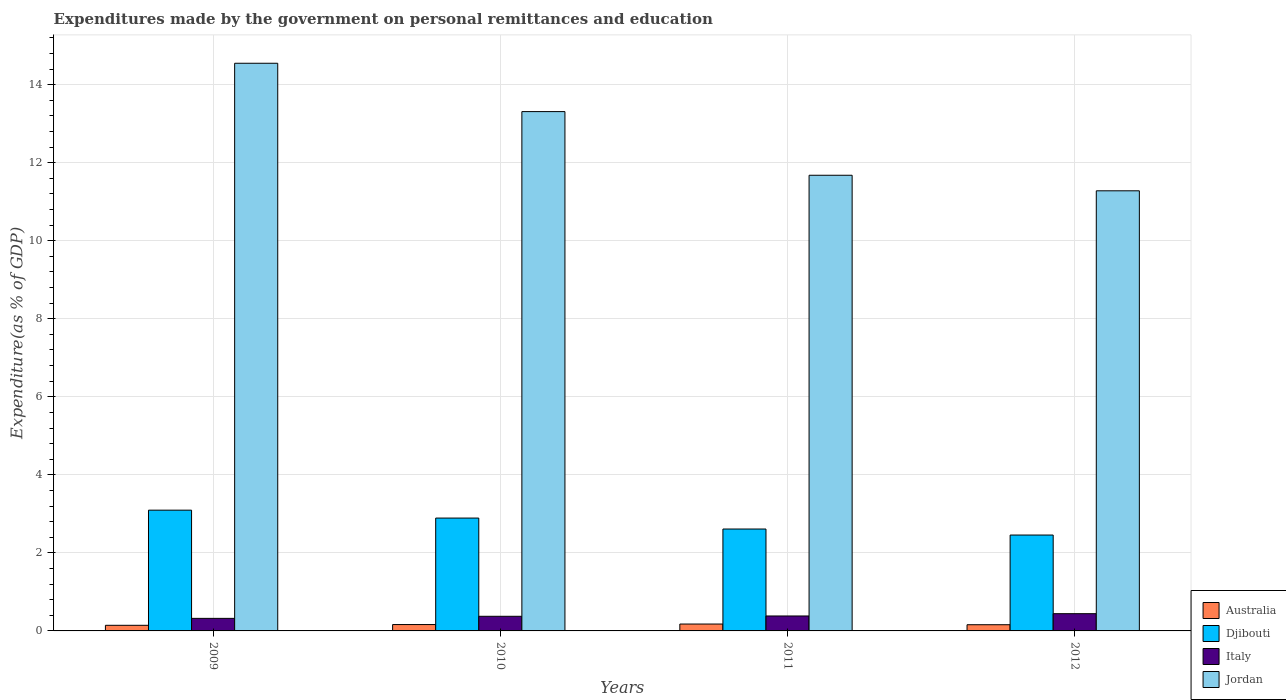How many groups of bars are there?
Ensure brevity in your answer.  4. Are the number of bars on each tick of the X-axis equal?
Provide a short and direct response. Yes. How many bars are there on the 1st tick from the left?
Your answer should be compact. 4. What is the expenditures made by the government on personal remittances and education in Australia in 2011?
Ensure brevity in your answer.  0.18. Across all years, what is the maximum expenditures made by the government on personal remittances and education in Australia?
Offer a very short reply. 0.18. Across all years, what is the minimum expenditures made by the government on personal remittances and education in Djibouti?
Your response must be concise. 2.46. What is the total expenditures made by the government on personal remittances and education in Italy in the graph?
Ensure brevity in your answer.  1.52. What is the difference between the expenditures made by the government on personal remittances and education in Australia in 2010 and that in 2012?
Make the answer very short. 0. What is the difference between the expenditures made by the government on personal remittances and education in Australia in 2011 and the expenditures made by the government on personal remittances and education in Jordan in 2009?
Your answer should be very brief. -14.37. What is the average expenditures made by the government on personal remittances and education in Italy per year?
Offer a terse response. 0.38. In the year 2011, what is the difference between the expenditures made by the government on personal remittances and education in Italy and expenditures made by the government on personal remittances and education in Jordan?
Keep it short and to the point. -11.3. In how many years, is the expenditures made by the government on personal remittances and education in Djibouti greater than 2.8 %?
Provide a succinct answer. 2. What is the ratio of the expenditures made by the government on personal remittances and education in Australia in 2009 to that in 2010?
Offer a very short reply. 0.88. Is the expenditures made by the government on personal remittances and education in Jordan in 2011 less than that in 2012?
Make the answer very short. No. What is the difference between the highest and the second highest expenditures made by the government on personal remittances and education in Australia?
Ensure brevity in your answer.  0.01. What is the difference between the highest and the lowest expenditures made by the government on personal remittances and education in Djibouti?
Keep it short and to the point. 0.64. What does the 4th bar from the left in 2009 represents?
Provide a short and direct response. Jordan. Is it the case that in every year, the sum of the expenditures made by the government on personal remittances and education in Italy and expenditures made by the government on personal remittances and education in Djibouti is greater than the expenditures made by the government on personal remittances and education in Jordan?
Provide a succinct answer. No. Does the graph contain grids?
Offer a terse response. Yes. How many legend labels are there?
Ensure brevity in your answer.  4. What is the title of the graph?
Provide a succinct answer. Expenditures made by the government on personal remittances and education. Does "Aruba" appear as one of the legend labels in the graph?
Provide a short and direct response. No. What is the label or title of the X-axis?
Your response must be concise. Years. What is the label or title of the Y-axis?
Your answer should be compact. Expenditure(as % of GDP). What is the Expenditure(as % of GDP) in Australia in 2009?
Keep it short and to the point. 0.14. What is the Expenditure(as % of GDP) in Djibouti in 2009?
Offer a terse response. 3.09. What is the Expenditure(as % of GDP) in Italy in 2009?
Provide a short and direct response. 0.32. What is the Expenditure(as % of GDP) in Jordan in 2009?
Ensure brevity in your answer.  14.55. What is the Expenditure(as % of GDP) of Australia in 2010?
Provide a succinct answer. 0.16. What is the Expenditure(as % of GDP) of Djibouti in 2010?
Provide a succinct answer. 2.89. What is the Expenditure(as % of GDP) of Italy in 2010?
Ensure brevity in your answer.  0.38. What is the Expenditure(as % of GDP) of Jordan in 2010?
Your response must be concise. 13.31. What is the Expenditure(as % of GDP) of Australia in 2011?
Ensure brevity in your answer.  0.18. What is the Expenditure(as % of GDP) in Djibouti in 2011?
Ensure brevity in your answer.  2.61. What is the Expenditure(as % of GDP) of Italy in 2011?
Offer a very short reply. 0.38. What is the Expenditure(as % of GDP) in Jordan in 2011?
Your answer should be very brief. 11.68. What is the Expenditure(as % of GDP) in Australia in 2012?
Give a very brief answer. 0.16. What is the Expenditure(as % of GDP) in Djibouti in 2012?
Your answer should be compact. 2.46. What is the Expenditure(as % of GDP) of Italy in 2012?
Your answer should be compact. 0.44. What is the Expenditure(as % of GDP) in Jordan in 2012?
Ensure brevity in your answer.  11.28. Across all years, what is the maximum Expenditure(as % of GDP) in Australia?
Keep it short and to the point. 0.18. Across all years, what is the maximum Expenditure(as % of GDP) of Djibouti?
Make the answer very short. 3.09. Across all years, what is the maximum Expenditure(as % of GDP) in Italy?
Offer a very short reply. 0.44. Across all years, what is the maximum Expenditure(as % of GDP) of Jordan?
Provide a short and direct response. 14.55. Across all years, what is the minimum Expenditure(as % of GDP) in Australia?
Your answer should be very brief. 0.14. Across all years, what is the minimum Expenditure(as % of GDP) of Djibouti?
Provide a succinct answer. 2.46. Across all years, what is the minimum Expenditure(as % of GDP) in Italy?
Provide a succinct answer. 0.32. Across all years, what is the minimum Expenditure(as % of GDP) of Jordan?
Keep it short and to the point. 11.28. What is the total Expenditure(as % of GDP) in Australia in the graph?
Ensure brevity in your answer.  0.64. What is the total Expenditure(as % of GDP) of Djibouti in the graph?
Provide a succinct answer. 11.06. What is the total Expenditure(as % of GDP) of Italy in the graph?
Provide a succinct answer. 1.52. What is the total Expenditure(as % of GDP) in Jordan in the graph?
Offer a terse response. 50.82. What is the difference between the Expenditure(as % of GDP) of Australia in 2009 and that in 2010?
Your response must be concise. -0.02. What is the difference between the Expenditure(as % of GDP) in Djibouti in 2009 and that in 2010?
Give a very brief answer. 0.2. What is the difference between the Expenditure(as % of GDP) of Italy in 2009 and that in 2010?
Keep it short and to the point. -0.05. What is the difference between the Expenditure(as % of GDP) of Jordan in 2009 and that in 2010?
Your answer should be very brief. 1.24. What is the difference between the Expenditure(as % of GDP) of Australia in 2009 and that in 2011?
Your answer should be very brief. -0.03. What is the difference between the Expenditure(as % of GDP) in Djibouti in 2009 and that in 2011?
Offer a very short reply. 0.48. What is the difference between the Expenditure(as % of GDP) of Italy in 2009 and that in 2011?
Provide a short and direct response. -0.06. What is the difference between the Expenditure(as % of GDP) of Jordan in 2009 and that in 2011?
Give a very brief answer. 2.87. What is the difference between the Expenditure(as % of GDP) of Australia in 2009 and that in 2012?
Your response must be concise. -0.01. What is the difference between the Expenditure(as % of GDP) of Djibouti in 2009 and that in 2012?
Your response must be concise. 0.64. What is the difference between the Expenditure(as % of GDP) in Italy in 2009 and that in 2012?
Make the answer very short. -0.12. What is the difference between the Expenditure(as % of GDP) of Jordan in 2009 and that in 2012?
Give a very brief answer. 3.27. What is the difference between the Expenditure(as % of GDP) in Australia in 2010 and that in 2011?
Your answer should be very brief. -0.01. What is the difference between the Expenditure(as % of GDP) in Djibouti in 2010 and that in 2011?
Offer a terse response. 0.28. What is the difference between the Expenditure(as % of GDP) of Italy in 2010 and that in 2011?
Ensure brevity in your answer.  -0.01. What is the difference between the Expenditure(as % of GDP) of Jordan in 2010 and that in 2011?
Keep it short and to the point. 1.63. What is the difference between the Expenditure(as % of GDP) of Australia in 2010 and that in 2012?
Offer a very short reply. 0. What is the difference between the Expenditure(as % of GDP) in Djibouti in 2010 and that in 2012?
Keep it short and to the point. 0.43. What is the difference between the Expenditure(as % of GDP) in Italy in 2010 and that in 2012?
Your response must be concise. -0.07. What is the difference between the Expenditure(as % of GDP) of Jordan in 2010 and that in 2012?
Your answer should be compact. 2.03. What is the difference between the Expenditure(as % of GDP) in Australia in 2011 and that in 2012?
Your response must be concise. 0.02. What is the difference between the Expenditure(as % of GDP) of Djibouti in 2011 and that in 2012?
Provide a short and direct response. 0.15. What is the difference between the Expenditure(as % of GDP) of Italy in 2011 and that in 2012?
Your answer should be compact. -0.06. What is the difference between the Expenditure(as % of GDP) of Jordan in 2011 and that in 2012?
Keep it short and to the point. 0.4. What is the difference between the Expenditure(as % of GDP) of Australia in 2009 and the Expenditure(as % of GDP) of Djibouti in 2010?
Give a very brief answer. -2.75. What is the difference between the Expenditure(as % of GDP) in Australia in 2009 and the Expenditure(as % of GDP) in Italy in 2010?
Provide a short and direct response. -0.23. What is the difference between the Expenditure(as % of GDP) in Australia in 2009 and the Expenditure(as % of GDP) in Jordan in 2010?
Provide a succinct answer. -13.17. What is the difference between the Expenditure(as % of GDP) of Djibouti in 2009 and the Expenditure(as % of GDP) of Italy in 2010?
Ensure brevity in your answer.  2.72. What is the difference between the Expenditure(as % of GDP) of Djibouti in 2009 and the Expenditure(as % of GDP) of Jordan in 2010?
Offer a terse response. -10.21. What is the difference between the Expenditure(as % of GDP) of Italy in 2009 and the Expenditure(as % of GDP) of Jordan in 2010?
Provide a succinct answer. -12.99. What is the difference between the Expenditure(as % of GDP) in Australia in 2009 and the Expenditure(as % of GDP) in Djibouti in 2011?
Provide a short and direct response. -2.47. What is the difference between the Expenditure(as % of GDP) of Australia in 2009 and the Expenditure(as % of GDP) of Italy in 2011?
Give a very brief answer. -0.24. What is the difference between the Expenditure(as % of GDP) of Australia in 2009 and the Expenditure(as % of GDP) of Jordan in 2011?
Provide a succinct answer. -11.53. What is the difference between the Expenditure(as % of GDP) in Djibouti in 2009 and the Expenditure(as % of GDP) in Italy in 2011?
Keep it short and to the point. 2.71. What is the difference between the Expenditure(as % of GDP) in Djibouti in 2009 and the Expenditure(as % of GDP) in Jordan in 2011?
Make the answer very short. -8.58. What is the difference between the Expenditure(as % of GDP) in Italy in 2009 and the Expenditure(as % of GDP) in Jordan in 2011?
Provide a short and direct response. -11.36. What is the difference between the Expenditure(as % of GDP) of Australia in 2009 and the Expenditure(as % of GDP) of Djibouti in 2012?
Offer a very short reply. -2.31. What is the difference between the Expenditure(as % of GDP) of Australia in 2009 and the Expenditure(as % of GDP) of Italy in 2012?
Offer a very short reply. -0.3. What is the difference between the Expenditure(as % of GDP) in Australia in 2009 and the Expenditure(as % of GDP) in Jordan in 2012?
Give a very brief answer. -11.14. What is the difference between the Expenditure(as % of GDP) in Djibouti in 2009 and the Expenditure(as % of GDP) in Italy in 2012?
Your response must be concise. 2.65. What is the difference between the Expenditure(as % of GDP) of Djibouti in 2009 and the Expenditure(as % of GDP) of Jordan in 2012?
Keep it short and to the point. -8.18. What is the difference between the Expenditure(as % of GDP) of Italy in 2009 and the Expenditure(as % of GDP) of Jordan in 2012?
Ensure brevity in your answer.  -10.96. What is the difference between the Expenditure(as % of GDP) in Australia in 2010 and the Expenditure(as % of GDP) in Djibouti in 2011?
Provide a succinct answer. -2.45. What is the difference between the Expenditure(as % of GDP) of Australia in 2010 and the Expenditure(as % of GDP) of Italy in 2011?
Provide a succinct answer. -0.22. What is the difference between the Expenditure(as % of GDP) of Australia in 2010 and the Expenditure(as % of GDP) of Jordan in 2011?
Ensure brevity in your answer.  -11.52. What is the difference between the Expenditure(as % of GDP) in Djibouti in 2010 and the Expenditure(as % of GDP) in Italy in 2011?
Offer a very short reply. 2.51. What is the difference between the Expenditure(as % of GDP) of Djibouti in 2010 and the Expenditure(as % of GDP) of Jordan in 2011?
Make the answer very short. -8.79. What is the difference between the Expenditure(as % of GDP) of Italy in 2010 and the Expenditure(as % of GDP) of Jordan in 2011?
Ensure brevity in your answer.  -11.3. What is the difference between the Expenditure(as % of GDP) in Australia in 2010 and the Expenditure(as % of GDP) in Djibouti in 2012?
Provide a succinct answer. -2.29. What is the difference between the Expenditure(as % of GDP) in Australia in 2010 and the Expenditure(as % of GDP) in Italy in 2012?
Make the answer very short. -0.28. What is the difference between the Expenditure(as % of GDP) in Australia in 2010 and the Expenditure(as % of GDP) in Jordan in 2012?
Give a very brief answer. -11.12. What is the difference between the Expenditure(as % of GDP) of Djibouti in 2010 and the Expenditure(as % of GDP) of Italy in 2012?
Offer a terse response. 2.45. What is the difference between the Expenditure(as % of GDP) of Djibouti in 2010 and the Expenditure(as % of GDP) of Jordan in 2012?
Give a very brief answer. -8.39. What is the difference between the Expenditure(as % of GDP) in Italy in 2010 and the Expenditure(as % of GDP) in Jordan in 2012?
Your answer should be very brief. -10.9. What is the difference between the Expenditure(as % of GDP) of Australia in 2011 and the Expenditure(as % of GDP) of Djibouti in 2012?
Provide a short and direct response. -2.28. What is the difference between the Expenditure(as % of GDP) of Australia in 2011 and the Expenditure(as % of GDP) of Italy in 2012?
Make the answer very short. -0.27. What is the difference between the Expenditure(as % of GDP) of Australia in 2011 and the Expenditure(as % of GDP) of Jordan in 2012?
Provide a succinct answer. -11.1. What is the difference between the Expenditure(as % of GDP) of Djibouti in 2011 and the Expenditure(as % of GDP) of Italy in 2012?
Your response must be concise. 2.17. What is the difference between the Expenditure(as % of GDP) of Djibouti in 2011 and the Expenditure(as % of GDP) of Jordan in 2012?
Keep it short and to the point. -8.67. What is the difference between the Expenditure(as % of GDP) in Italy in 2011 and the Expenditure(as % of GDP) in Jordan in 2012?
Offer a very short reply. -10.9. What is the average Expenditure(as % of GDP) in Australia per year?
Your answer should be compact. 0.16. What is the average Expenditure(as % of GDP) of Djibouti per year?
Make the answer very short. 2.76. What is the average Expenditure(as % of GDP) in Italy per year?
Your response must be concise. 0.38. What is the average Expenditure(as % of GDP) in Jordan per year?
Your response must be concise. 12.7. In the year 2009, what is the difference between the Expenditure(as % of GDP) in Australia and Expenditure(as % of GDP) in Djibouti?
Ensure brevity in your answer.  -2.95. In the year 2009, what is the difference between the Expenditure(as % of GDP) in Australia and Expenditure(as % of GDP) in Italy?
Give a very brief answer. -0.18. In the year 2009, what is the difference between the Expenditure(as % of GDP) of Australia and Expenditure(as % of GDP) of Jordan?
Offer a very short reply. -14.4. In the year 2009, what is the difference between the Expenditure(as % of GDP) of Djibouti and Expenditure(as % of GDP) of Italy?
Make the answer very short. 2.77. In the year 2009, what is the difference between the Expenditure(as % of GDP) of Djibouti and Expenditure(as % of GDP) of Jordan?
Ensure brevity in your answer.  -11.45. In the year 2009, what is the difference between the Expenditure(as % of GDP) of Italy and Expenditure(as % of GDP) of Jordan?
Offer a terse response. -14.23. In the year 2010, what is the difference between the Expenditure(as % of GDP) in Australia and Expenditure(as % of GDP) in Djibouti?
Provide a short and direct response. -2.73. In the year 2010, what is the difference between the Expenditure(as % of GDP) of Australia and Expenditure(as % of GDP) of Italy?
Offer a terse response. -0.21. In the year 2010, what is the difference between the Expenditure(as % of GDP) of Australia and Expenditure(as % of GDP) of Jordan?
Keep it short and to the point. -13.15. In the year 2010, what is the difference between the Expenditure(as % of GDP) in Djibouti and Expenditure(as % of GDP) in Italy?
Keep it short and to the point. 2.52. In the year 2010, what is the difference between the Expenditure(as % of GDP) in Djibouti and Expenditure(as % of GDP) in Jordan?
Make the answer very short. -10.42. In the year 2010, what is the difference between the Expenditure(as % of GDP) of Italy and Expenditure(as % of GDP) of Jordan?
Your answer should be very brief. -12.93. In the year 2011, what is the difference between the Expenditure(as % of GDP) in Australia and Expenditure(as % of GDP) in Djibouti?
Provide a short and direct response. -2.44. In the year 2011, what is the difference between the Expenditure(as % of GDP) in Australia and Expenditure(as % of GDP) in Italy?
Ensure brevity in your answer.  -0.21. In the year 2011, what is the difference between the Expenditure(as % of GDP) in Australia and Expenditure(as % of GDP) in Jordan?
Keep it short and to the point. -11.5. In the year 2011, what is the difference between the Expenditure(as % of GDP) in Djibouti and Expenditure(as % of GDP) in Italy?
Offer a terse response. 2.23. In the year 2011, what is the difference between the Expenditure(as % of GDP) of Djibouti and Expenditure(as % of GDP) of Jordan?
Ensure brevity in your answer.  -9.07. In the year 2011, what is the difference between the Expenditure(as % of GDP) of Italy and Expenditure(as % of GDP) of Jordan?
Your response must be concise. -11.3. In the year 2012, what is the difference between the Expenditure(as % of GDP) of Australia and Expenditure(as % of GDP) of Djibouti?
Offer a terse response. -2.3. In the year 2012, what is the difference between the Expenditure(as % of GDP) in Australia and Expenditure(as % of GDP) in Italy?
Offer a terse response. -0.28. In the year 2012, what is the difference between the Expenditure(as % of GDP) of Australia and Expenditure(as % of GDP) of Jordan?
Offer a terse response. -11.12. In the year 2012, what is the difference between the Expenditure(as % of GDP) of Djibouti and Expenditure(as % of GDP) of Italy?
Offer a very short reply. 2.02. In the year 2012, what is the difference between the Expenditure(as % of GDP) of Djibouti and Expenditure(as % of GDP) of Jordan?
Make the answer very short. -8.82. In the year 2012, what is the difference between the Expenditure(as % of GDP) of Italy and Expenditure(as % of GDP) of Jordan?
Provide a succinct answer. -10.84. What is the ratio of the Expenditure(as % of GDP) of Australia in 2009 to that in 2010?
Offer a terse response. 0.88. What is the ratio of the Expenditure(as % of GDP) of Djibouti in 2009 to that in 2010?
Your answer should be compact. 1.07. What is the ratio of the Expenditure(as % of GDP) in Italy in 2009 to that in 2010?
Your answer should be compact. 0.86. What is the ratio of the Expenditure(as % of GDP) in Jordan in 2009 to that in 2010?
Your response must be concise. 1.09. What is the ratio of the Expenditure(as % of GDP) in Australia in 2009 to that in 2011?
Provide a succinct answer. 0.82. What is the ratio of the Expenditure(as % of GDP) of Djibouti in 2009 to that in 2011?
Your answer should be compact. 1.19. What is the ratio of the Expenditure(as % of GDP) in Italy in 2009 to that in 2011?
Provide a succinct answer. 0.84. What is the ratio of the Expenditure(as % of GDP) in Jordan in 2009 to that in 2011?
Provide a short and direct response. 1.25. What is the ratio of the Expenditure(as % of GDP) of Australia in 2009 to that in 2012?
Give a very brief answer. 0.91. What is the ratio of the Expenditure(as % of GDP) in Djibouti in 2009 to that in 2012?
Your answer should be compact. 1.26. What is the ratio of the Expenditure(as % of GDP) of Italy in 2009 to that in 2012?
Give a very brief answer. 0.73. What is the ratio of the Expenditure(as % of GDP) in Jordan in 2009 to that in 2012?
Offer a very short reply. 1.29. What is the ratio of the Expenditure(as % of GDP) of Australia in 2010 to that in 2011?
Offer a terse response. 0.93. What is the ratio of the Expenditure(as % of GDP) of Djibouti in 2010 to that in 2011?
Provide a succinct answer. 1.11. What is the ratio of the Expenditure(as % of GDP) of Italy in 2010 to that in 2011?
Ensure brevity in your answer.  0.98. What is the ratio of the Expenditure(as % of GDP) in Jordan in 2010 to that in 2011?
Your answer should be compact. 1.14. What is the ratio of the Expenditure(as % of GDP) of Australia in 2010 to that in 2012?
Give a very brief answer. 1.03. What is the ratio of the Expenditure(as % of GDP) in Djibouti in 2010 to that in 2012?
Your answer should be very brief. 1.18. What is the ratio of the Expenditure(as % of GDP) of Italy in 2010 to that in 2012?
Provide a short and direct response. 0.85. What is the ratio of the Expenditure(as % of GDP) in Jordan in 2010 to that in 2012?
Provide a succinct answer. 1.18. What is the ratio of the Expenditure(as % of GDP) of Australia in 2011 to that in 2012?
Your answer should be compact. 1.11. What is the ratio of the Expenditure(as % of GDP) of Djibouti in 2011 to that in 2012?
Your response must be concise. 1.06. What is the ratio of the Expenditure(as % of GDP) in Italy in 2011 to that in 2012?
Offer a terse response. 0.87. What is the ratio of the Expenditure(as % of GDP) of Jordan in 2011 to that in 2012?
Offer a very short reply. 1.04. What is the difference between the highest and the second highest Expenditure(as % of GDP) in Australia?
Your response must be concise. 0.01. What is the difference between the highest and the second highest Expenditure(as % of GDP) of Djibouti?
Keep it short and to the point. 0.2. What is the difference between the highest and the second highest Expenditure(as % of GDP) in Italy?
Keep it short and to the point. 0.06. What is the difference between the highest and the second highest Expenditure(as % of GDP) of Jordan?
Provide a succinct answer. 1.24. What is the difference between the highest and the lowest Expenditure(as % of GDP) in Australia?
Give a very brief answer. 0.03. What is the difference between the highest and the lowest Expenditure(as % of GDP) in Djibouti?
Make the answer very short. 0.64. What is the difference between the highest and the lowest Expenditure(as % of GDP) in Italy?
Provide a short and direct response. 0.12. What is the difference between the highest and the lowest Expenditure(as % of GDP) in Jordan?
Your answer should be compact. 3.27. 